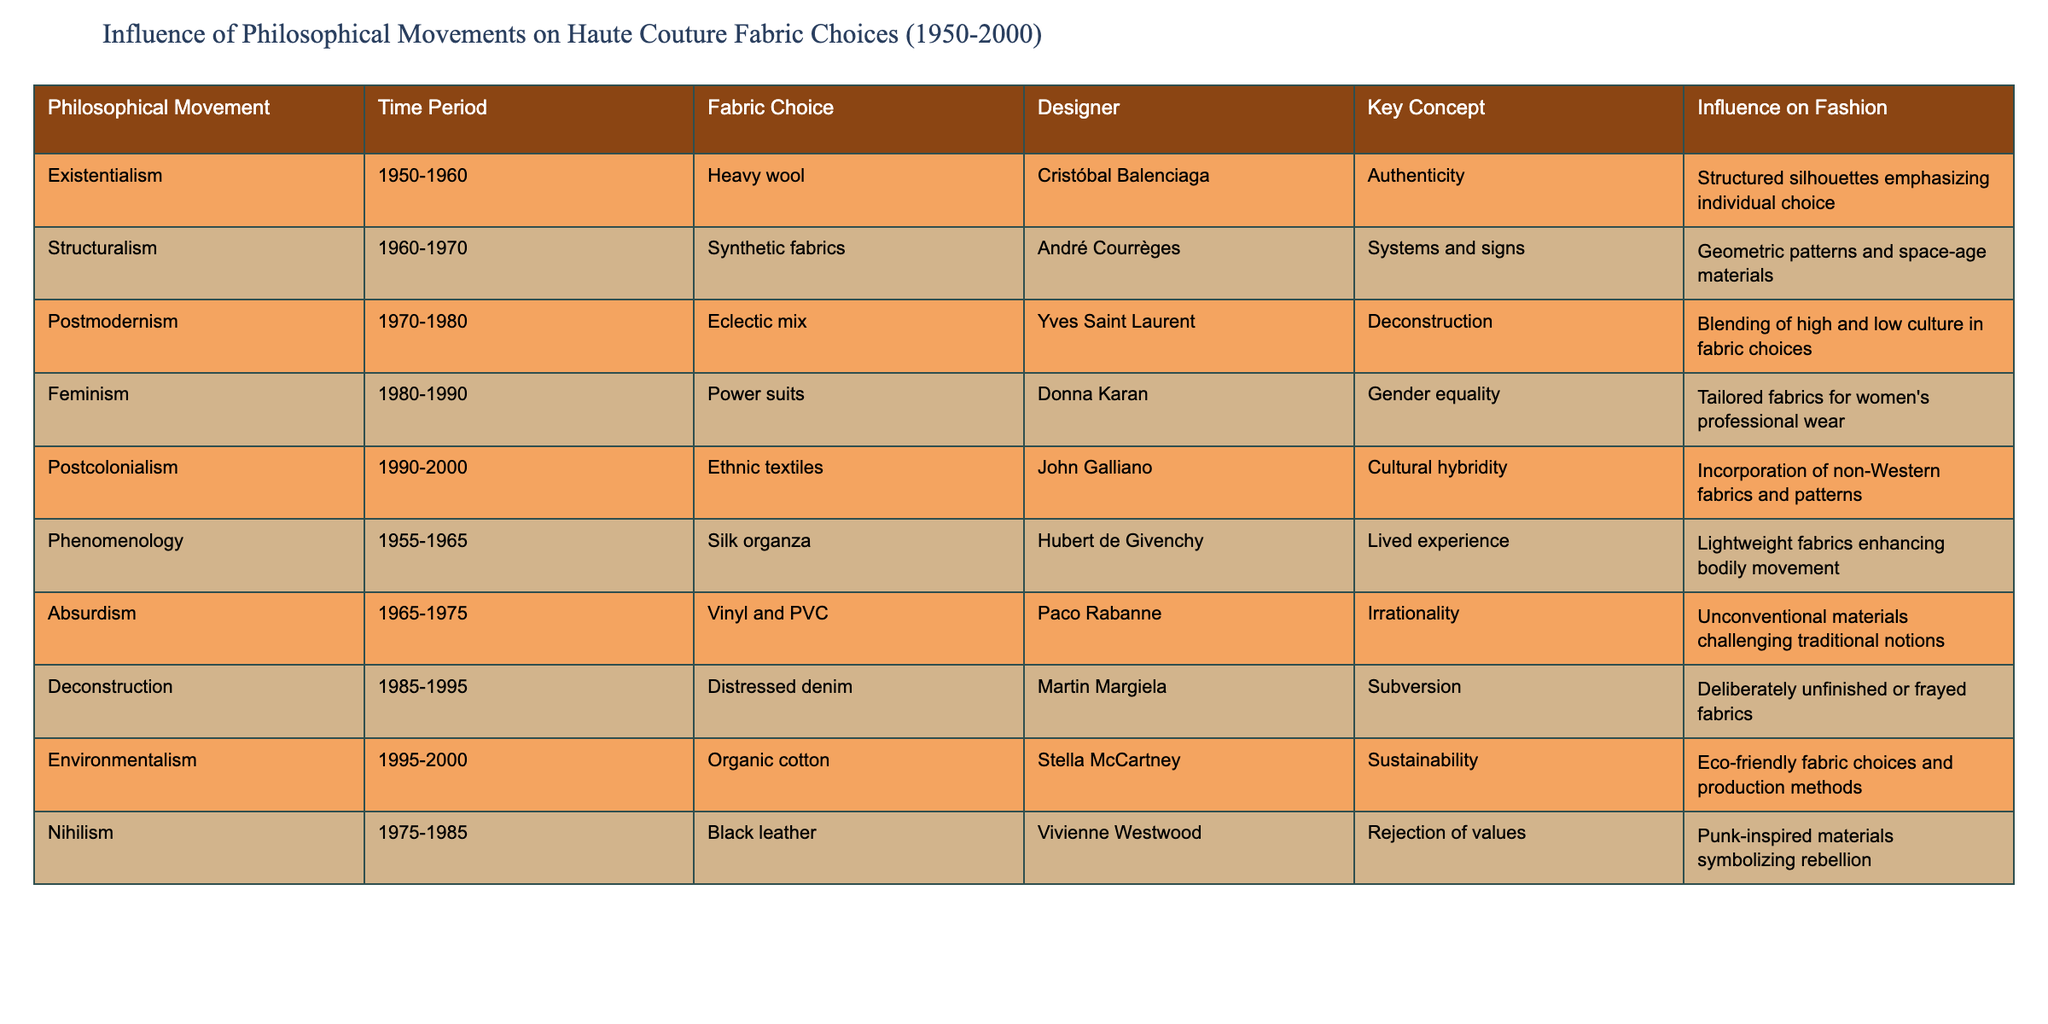What fabric choice is associated with Postcolonialism? Referring to the table, under the "Philosophical Movement" column, the fabric choice corresponding to "Postcolonialism" is listed as "Ethnic textiles."
Answer: Ethnic textiles Which designer is associated with feminism in the table? According to the table, the designer linked with "Feminism" is "Donna Karan."
Answer: Donna Karan How many different fabric choices were influenced by Existentialism and Absurdism combined? The table lists two fabric choices: "Heavy wool" for Existentialism and "Vinyl and PVC" for Absurdism. Therefore, the total is 2.
Answer: 2 Is there a fabric choice that reflects sustainability? The table indicates that "Organic cotton" is the fabric choice related to environmentalism, which denotes sustainability.
Answer: Yes What key concept is linked to the fabric choice of distressed denim? The table indicates that the key concept associated with "Distressed denim" is "Subversion," which relates to the philosophy of deconstruction.
Answer: Subversion How many time periods listed involve synthetic fabrics? The table specifies two time periods that include synthetic fabrics: "1960-1970" for Structuralism and "1965-1975" for Absurdism. Sum = 2.
Answer: 2 Which two philosophical movements are connected to the fabric choice of black leather? The table shows that "Black leather" is associated with "Nihilism," but there are no other movements listed that correlate with this fabric.
Answer: Nihilism only What was the influence on fashion during the 1990-2000 period according to the table? Looking at the time period "1990-2000," the influence on fashion noted is "Incorporation of non-Western fabrics and patterns," linked with Postcolonialism.
Answer: Incorporation of non-Western fabrics and patterns Which fabric choice indicates a challenge to traditional notions? The table identifies "Vinyl and PVC" as the fabric choice for Absurdism, which embodies a challenge to traditional norms.
Answer: Vinyl and PVC What do the philosophies of Structuralism and Postmodernism contribute to fashion similarly? Both movements influence fashion by utilizing contrasting materials: Structuralism uses synthetic fabrics for geometric patterns, while Postmodernism incorporates an eclectic mix, reflecting high and low culture blending.
Answer: Use of diverse materials reflecting complexity Which designer is recognized for promoting gender equality through tailored fabrics? The table states that "Donna Karan" is the designer who promoted gender equality through the choice of power suits, illustrating the feminist movement.
Answer: Donna Karan 